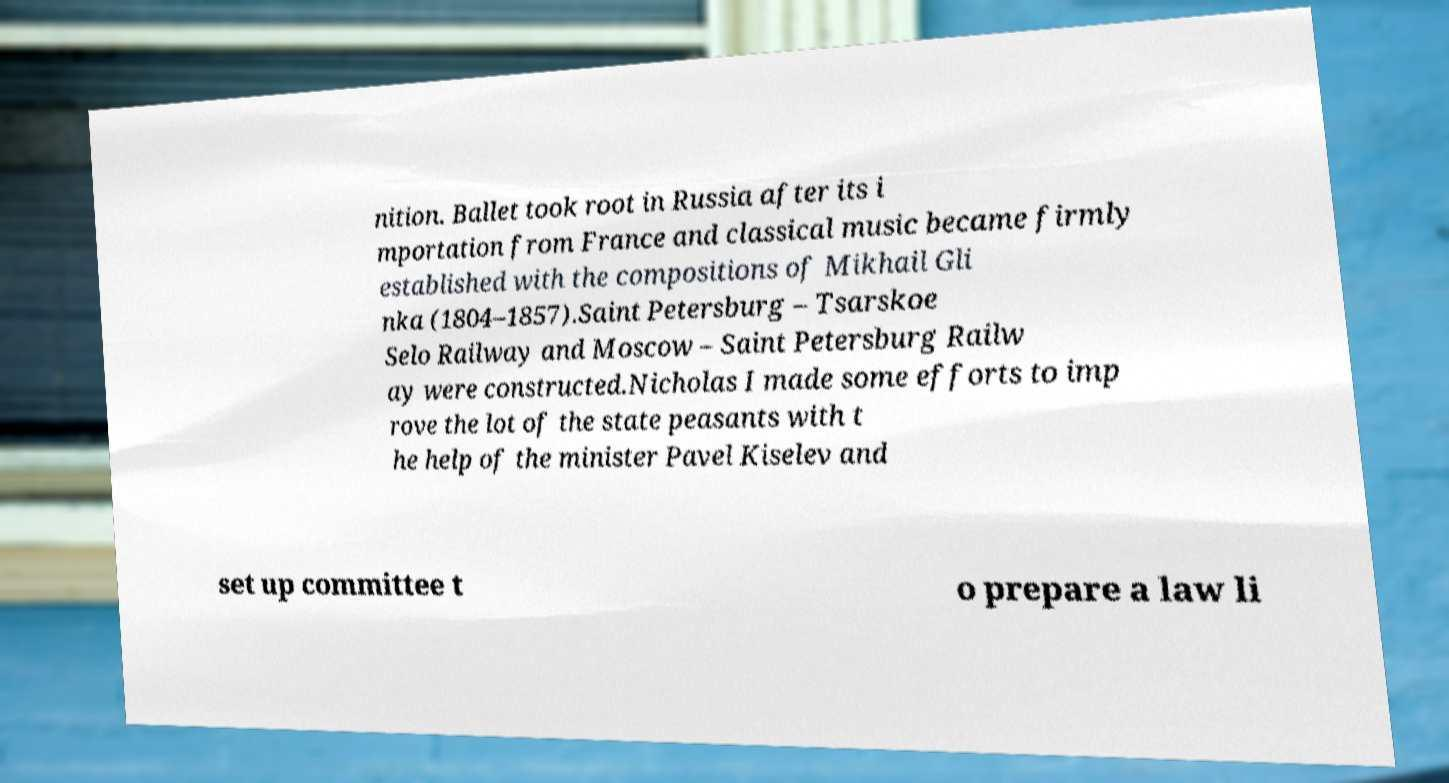For documentation purposes, I need the text within this image transcribed. Could you provide that? nition. Ballet took root in Russia after its i mportation from France and classical music became firmly established with the compositions of Mikhail Gli nka (1804–1857).Saint Petersburg – Tsarskoe Selo Railway and Moscow – Saint Petersburg Railw ay were constructed.Nicholas I made some efforts to imp rove the lot of the state peasants with t he help of the minister Pavel Kiselev and set up committee t o prepare a law li 